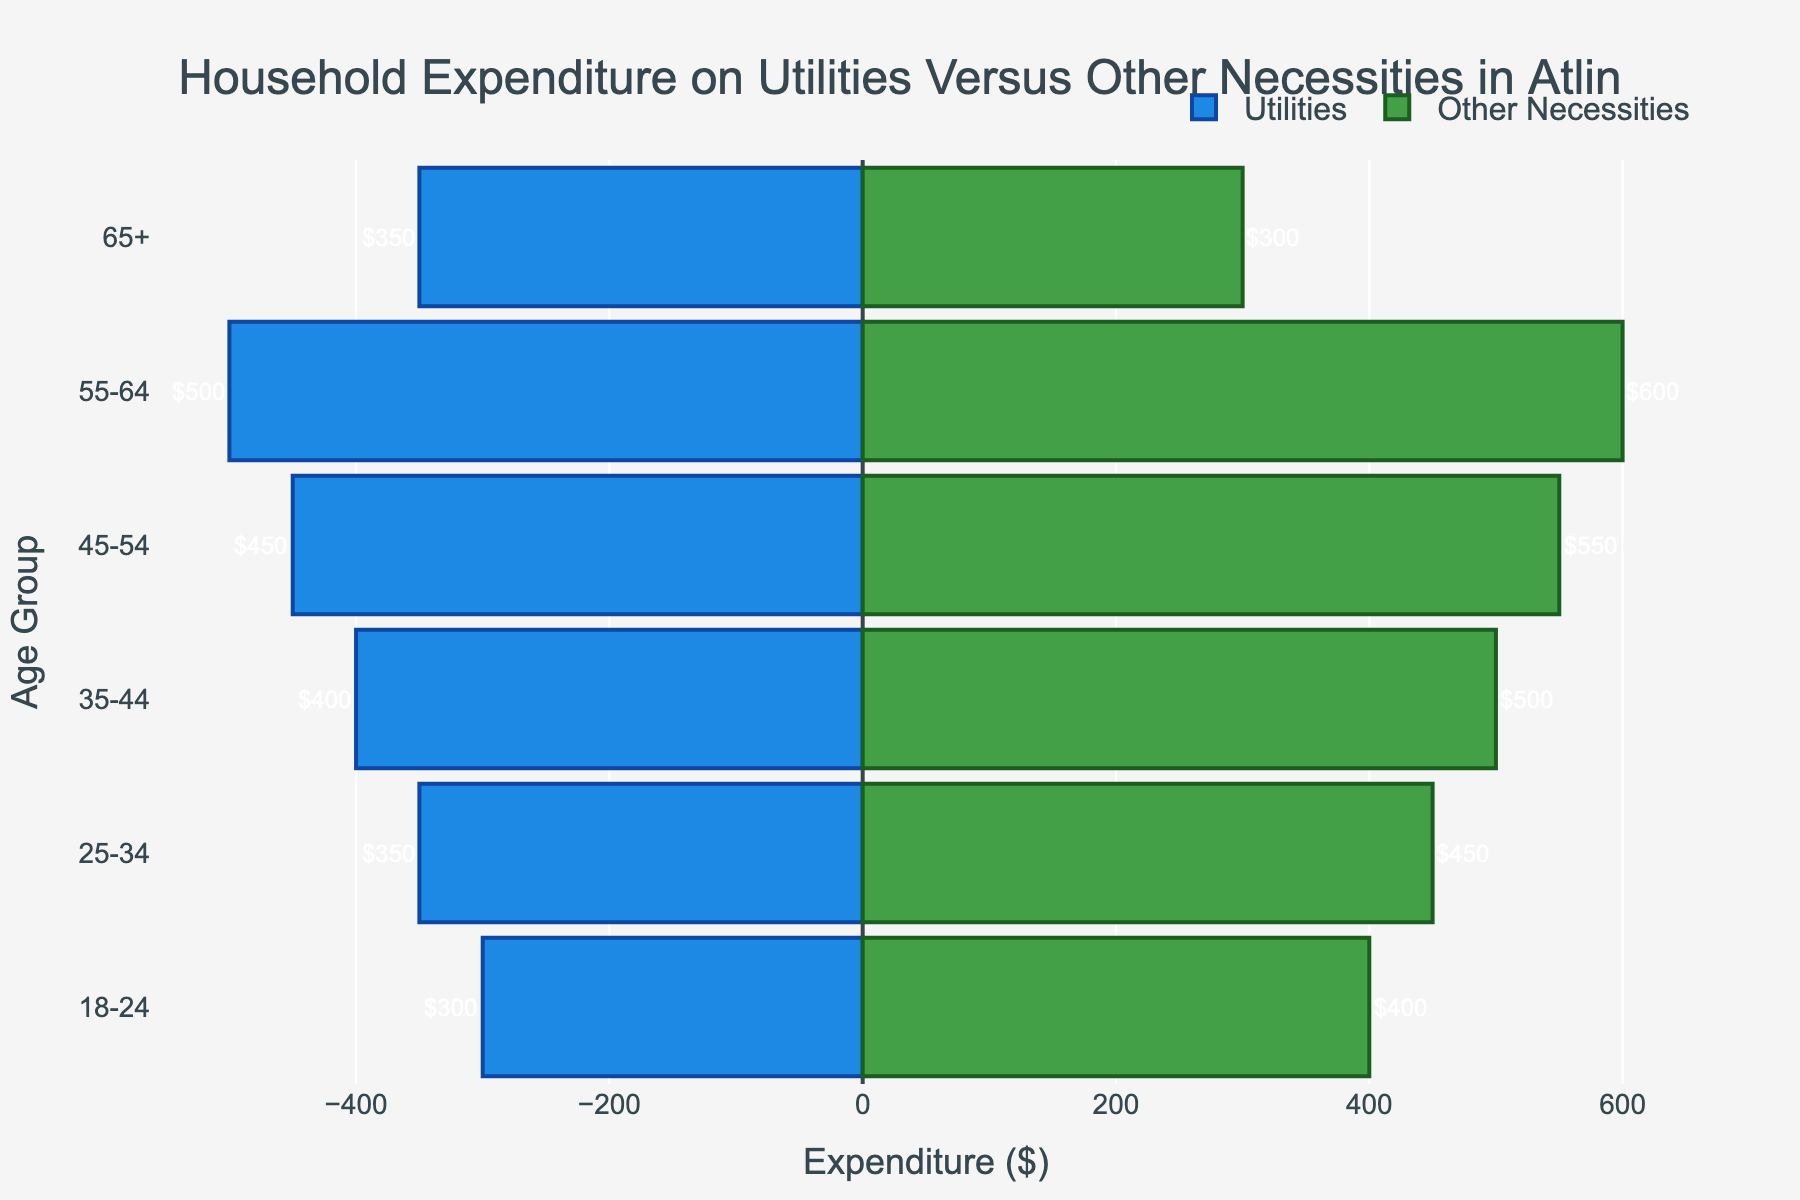What is the difference in expenditure on utilities between the 55-64 age group and the 18-24 age group? The expenditure on utilities for the 55-64 age group is $500, and for the 18-24 age group, it is $300. The difference is calculated as $500 - $300.
Answer: $200 Which age group spends the most on other necessities? By looking at the bars representing expenditures on other necessities, the 55-64 age group has the highest bar at $600.
Answer: 55-64 What is the combined expenditure on utilities and other necessities for the 65+ age group? The 65+ age group spends $350 on utilities and $300 on other necessities. Adding these together, $350 + $300 equals $650.
Answer: $650 Which age group spends the least on other necessities? The smallest bar for other necessities is observed for the 18-24 age group at $400.
Answer: 18-24 How much more does the 45-54 age group spend on other necessities than the 45-54 age group spends on utilities? The 45-54 age group spends $550 on other necessities and $450 on utilities. The difference is $550 - $450.
Answer: $100 Do any age groups spend the same amount on both utilities and other necessities? By examining the bars, the 65+ age group spends $350 on utilities and $300 on other necessities, which are the closest but not the same. Thus, no age groups have the same expenditure on both categories.
Answer: No What is the average expenditure on other necessities across all age groups? The expenditures on other necessities across age groups are $400, $450, $500, $550, $600, and $300. Adding these, 400 + 450 + 500 + 550 + 600 + 300 equals $2800. The average is $2800 / 6.
Answer: $466.67 What age group has the highest total expenditure when combining utilities and other necessities? By adding the expenditures in both categories, we get:
- 18-24: $300 + $400 = $700
- 25-34: $350 + $450 = $800
- 35-44: $400 + $500 = $900
- 45-54: $450 + $550 = $1000
- 55-64: $500 + $600 = $1100
- 65+: $350 + $300 = $650
The highest total expenditure is for the 55-64 age group.
Answer: 55-64 